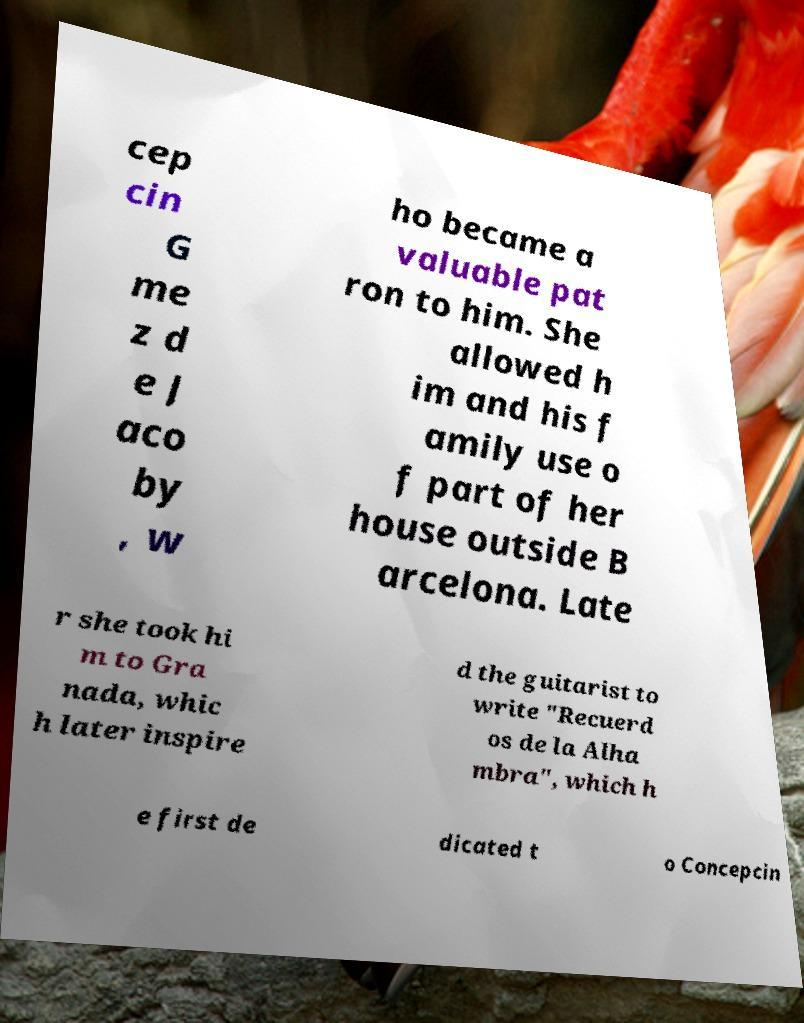Please read and relay the text visible in this image. What does it say? cep cin G me z d e J aco by , w ho became a valuable pat ron to him. She allowed h im and his f amily use o f part of her house outside B arcelona. Late r she took hi m to Gra nada, whic h later inspire d the guitarist to write "Recuerd os de la Alha mbra", which h e first de dicated t o Concepcin 